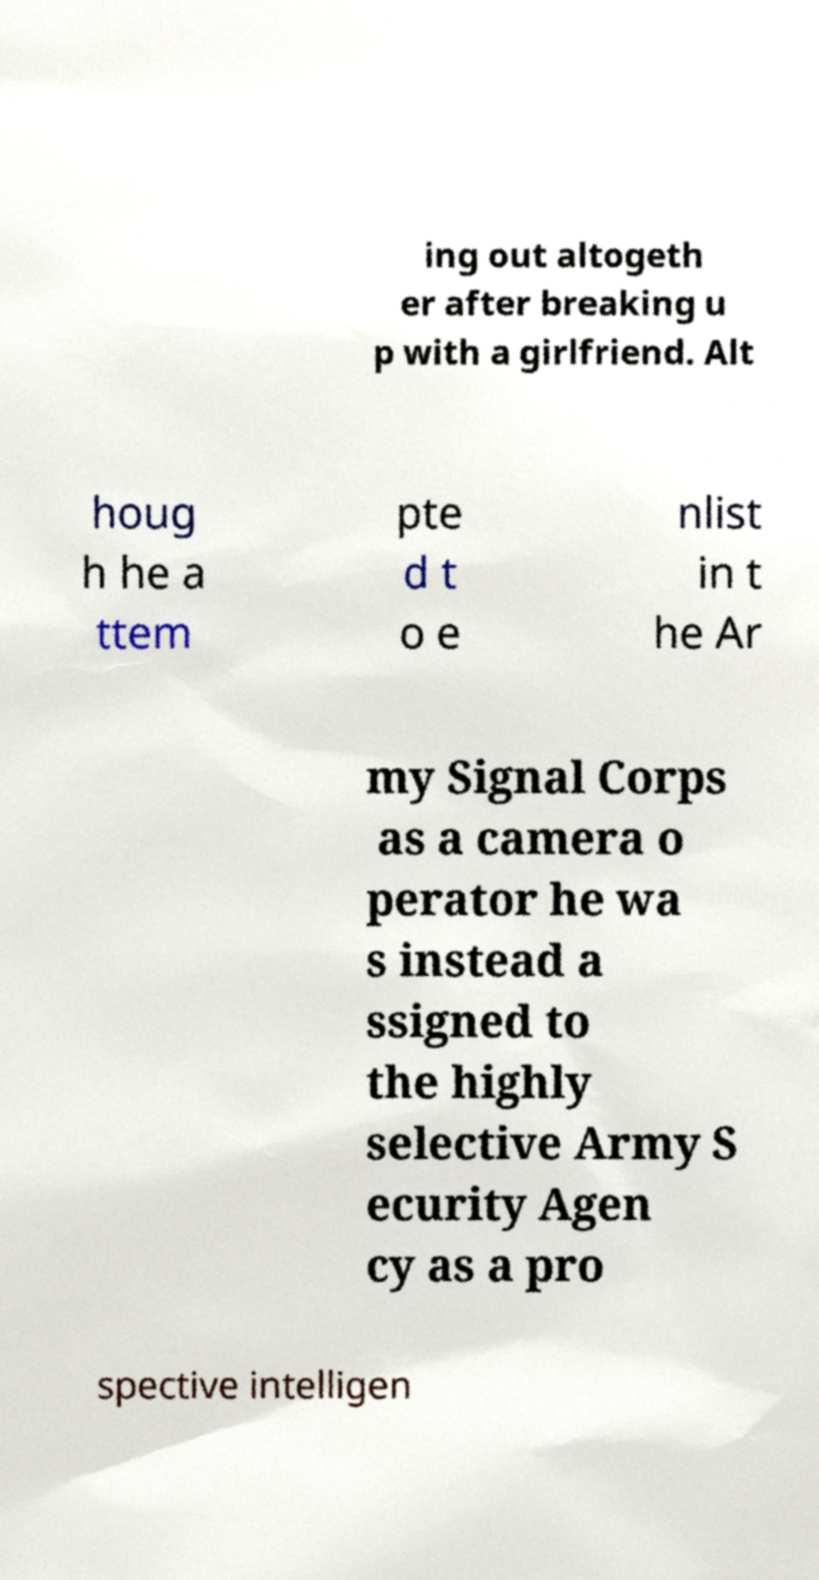Please read and relay the text visible in this image. What does it say? ing out altogeth er after breaking u p with a girlfriend. Alt houg h he a ttem pte d t o e nlist in t he Ar my Signal Corps as a camera o perator he wa s instead a ssigned to the highly selective Army S ecurity Agen cy as a pro spective intelligen 